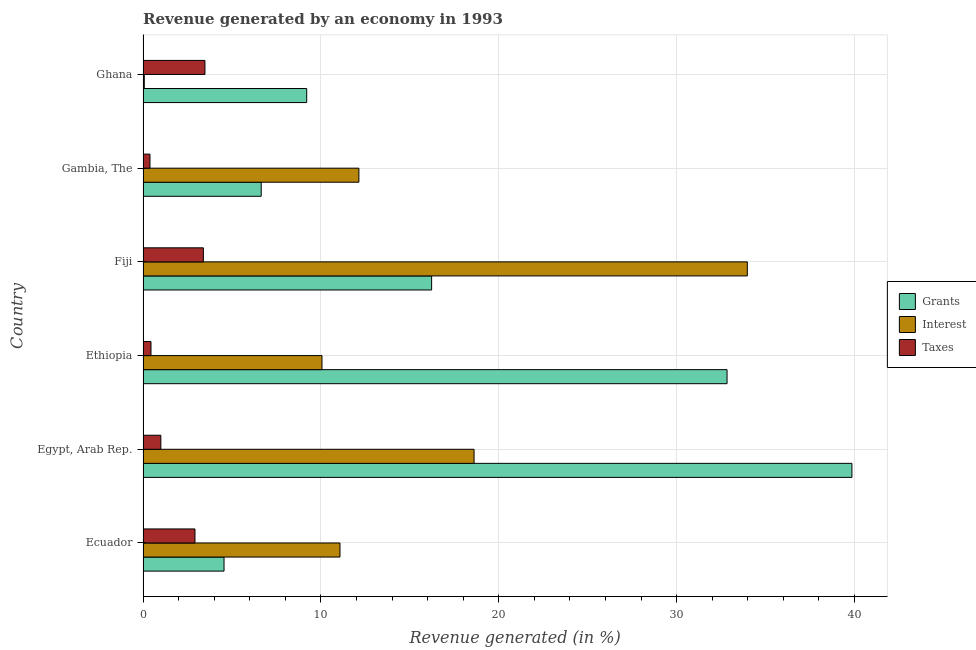How many different coloured bars are there?
Your response must be concise. 3. How many groups of bars are there?
Provide a succinct answer. 6. Are the number of bars per tick equal to the number of legend labels?
Give a very brief answer. Yes. How many bars are there on the 6th tick from the bottom?
Offer a very short reply. 3. What is the label of the 5th group of bars from the top?
Your answer should be very brief. Egypt, Arab Rep. What is the percentage of revenue generated by interest in Fiji?
Provide a succinct answer. 33.97. Across all countries, what is the maximum percentage of revenue generated by interest?
Make the answer very short. 33.97. Across all countries, what is the minimum percentage of revenue generated by taxes?
Your answer should be compact. 0.39. In which country was the percentage of revenue generated by interest maximum?
Keep it short and to the point. Fiji. In which country was the percentage of revenue generated by interest minimum?
Make the answer very short. Ghana. What is the total percentage of revenue generated by interest in the graph?
Your answer should be very brief. 85.92. What is the difference between the percentage of revenue generated by grants in Ethiopia and that in Gambia, The?
Ensure brevity in your answer.  26.19. What is the difference between the percentage of revenue generated by taxes in Ecuador and the percentage of revenue generated by grants in Ethiopia?
Offer a very short reply. -29.92. What is the average percentage of revenue generated by interest per country?
Offer a terse response. 14.32. What is the difference between the percentage of revenue generated by taxes and percentage of revenue generated by interest in Ethiopia?
Make the answer very short. -9.61. What is the ratio of the percentage of revenue generated by grants in Ethiopia to that in Fiji?
Provide a succinct answer. 2.02. Is the percentage of revenue generated by taxes in Egypt, Arab Rep. less than that in Gambia, The?
Your answer should be compact. No. Is the difference between the percentage of revenue generated by taxes in Ecuador and Egypt, Arab Rep. greater than the difference between the percentage of revenue generated by grants in Ecuador and Egypt, Arab Rep.?
Provide a succinct answer. Yes. What is the difference between the highest and the second highest percentage of revenue generated by grants?
Offer a terse response. 7.02. What is the difference between the highest and the lowest percentage of revenue generated by taxes?
Offer a terse response. 3.09. Is the sum of the percentage of revenue generated by taxes in Ecuador and Fiji greater than the maximum percentage of revenue generated by interest across all countries?
Make the answer very short. No. What does the 2nd bar from the top in Ethiopia represents?
Your answer should be compact. Interest. What does the 3rd bar from the bottom in Gambia, The represents?
Keep it short and to the point. Taxes. Is it the case that in every country, the sum of the percentage of revenue generated by grants and percentage of revenue generated by interest is greater than the percentage of revenue generated by taxes?
Your answer should be compact. Yes. Are all the bars in the graph horizontal?
Your answer should be very brief. Yes. How many countries are there in the graph?
Offer a terse response. 6. What is the difference between two consecutive major ticks on the X-axis?
Your response must be concise. 10. Are the values on the major ticks of X-axis written in scientific E-notation?
Ensure brevity in your answer.  No. Does the graph contain any zero values?
Give a very brief answer. No. Where does the legend appear in the graph?
Your response must be concise. Center right. How are the legend labels stacked?
Give a very brief answer. Vertical. What is the title of the graph?
Give a very brief answer. Revenue generated by an economy in 1993. Does "Methane" appear as one of the legend labels in the graph?
Provide a succinct answer. No. What is the label or title of the X-axis?
Offer a very short reply. Revenue generated (in %). What is the Revenue generated (in %) of Grants in Ecuador?
Make the answer very short. 4.55. What is the Revenue generated (in %) of Interest in Ecuador?
Provide a short and direct response. 11.07. What is the Revenue generated (in %) in Taxes in Ecuador?
Ensure brevity in your answer.  2.92. What is the Revenue generated (in %) of Grants in Egypt, Arab Rep.?
Keep it short and to the point. 39.86. What is the Revenue generated (in %) in Interest in Egypt, Arab Rep.?
Your response must be concise. 18.61. What is the Revenue generated (in %) in Taxes in Egypt, Arab Rep.?
Offer a very short reply. 1. What is the Revenue generated (in %) of Grants in Ethiopia?
Provide a succinct answer. 32.83. What is the Revenue generated (in %) in Interest in Ethiopia?
Offer a terse response. 10.06. What is the Revenue generated (in %) of Taxes in Ethiopia?
Offer a terse response. 0.45. What is the Revenue generated (in %) in Grants in Fiji?
Your answer should be compact. 16.22. What is the Revenue generated (in %) of Interest in Fiji?
Provide a short and direct response. 33.97. What is the Revenue generated (in %) in Taxes in Fiji?
Ensure brevity in your answer.  3.39. What is the Revenue generated (in %) of Grants in Gambia, The?
Keep it short and to the point. 6.64. What is the Revenue generated (in %) in Interest in Gambia, The?
Give a very brief answer. 12.13. What is the Revenue generated (in %) in Taxes in Gambia, The?
Offer a very short reply. 0.39. What is the Revenue generated (in %) of Grants in Ghana?
Provide a short and direct response. 9.2. What is the Revenue generated (in %) of Interest in Ghana?
Provide a succinct answer. 0.07. What is the Revenue generated (in %) of Taxes in Ghana?
Provide a succinct answer. 3.48. Across all countries, what is the maximum Revenue generated (in %) in Grants?
Your answer should be very brief. 39.86. Across all countries, what is the maximum Revenue generated (in %) of Interest?
Provide a short and direct response. 33.97. Across all countries, what is the maximum Revenue generated (in %) of Taxes?
Offer a very short reply. 3.48. Across all countries, what is the minimum Revenue generated (in %) in Grants?
Make the answer very short. 4.55. Across all countries, what is the minimum Revenue generated (in %) in Interest?
Give a very brief answer. 0.07. Across all countries, what is the minimum Revenue generated (in %) of Taxes?
Ensure brevity in your answer.  0.39. What is the total Revenue generated (in %) of Grants in the graph?
Provide a short and direct response. 109.31. What is the total Revenue generated (in %) in Interest in the graph?
Keep it short and to the point. 85.92. What is the total Revenue generated (in %) of Taxes in the graph?
Give a very brief answer. 11.62. What is the difference between the Revenue generated (in %) of Grants in Ecuador and that in Egypt, Arab Rep.?
Make the answer very short. -35.3. What is the difference between the Revenue generated (in %) of Interest in Ecuador and that in Egypt, Arab Rep.?
Your answer should be very brief. -7.54. What is the difference between the Revenue generated (in %) of Taxes in Ecuador and that in Egypt, Arab Rep.?
Your answer should be very brief. 1.92. What is the difference between the Revenue generated (in %) in Grants in Ecuador and that in Ethiopia?
Provide a succinct answer. -28.28. What is the difference between the Revenue generated (in %) of Interest in Ecuador and that in Ethiopia?
Your response must be concise. 1.01. What is the difference between the Revenue generated (in %) in Taxes in Ecuador and that in Ethiopia?
Keep it short and to the point. 2.47. What is the difference between the Revenue generated (in %) of Grants in Ecuador and that in Fiji?
Offer a very short reply. -11.67. What is the difference between the Revenue generated (in %) of Interest in Ecuador and that in Fiji?
Your answer should be compact. -22.9. What is the difference between the Revenue generated (in %) of Taxes in Ecuador and that in Fiji?
Your answer should be very brief. -0.47. What is the difference between the Revenue generated (in %) of Grants in Ecuador and that in Gambia, The?
Offer a terse response. -2.09. What is the difference between the Revenue generated (in %) of Interest in Ecuador and that in Gambia, The?
Offer a terse response. -1.06. What is the difference between the Revenue generated (in %) in Taxes in Ecuador and that in Gambia, The?
Give a very brief answer. 2.53. What is the difference between the Revenue generated (in %) of Grants in Ecuador and that in Ghana?
Provide a succinct answer. -4.65. What is the difference between the Revenue generated (in %) of Interest in Ecuador and that in Ghana?
Your answer should be compact. 11. What is the difference between the Revenue generated (in %) in Taxes in Ecuador and that in Ghana?
Provide a succinct answer. -0.56. What is the difference between the Revenue generated (in %) of Grants in Egypt, Arab Rep. and that in Ethiopia?
Offer a terse response. 7.02. What is the difference between the Revenue generated (in %) in Interest in Egypt, Arab Rep. and that in Ethiopia?
Keep it short and to the point. 8.55. What is the difference between the Revenue generated (in %) in Taxes in Egypt, Arab Rep. and that in Ethiopia?
Give a very brief answer. 0.55. What is the difference between the Revenue generated (in %) of Grants in Egypt, Arab Rep. and that in Fiji?
Make the answer very short. 23.63. What is the difference between the Revenue generated (in %) of Interest in Egypt, Arab Rep. and that in Fiji?
Provide a succinct answer. -15.36. What is the difference between the Revenue generated (in %) of Taxes in Egypt, Arab Rep. and that in Fiji?
Give a very brief answer. -2.39. What is the difference between the Revenue generated (in %) of Grants in Egypt, Arab Rep. and that in Gambia, The?
Your response must be concise. 33.21. What is the difference between the Revenue generated (in %) of Interest in Egypt, Arab Rep. and that in Gambia, The?
Your response must be concise. 6.48. What is the difference between the Revenue generated (in %) of Taxes in Egypt, Arab Rep. and that in Gambia, The?
Ensure brevity in your answer.  0.61. What is the difference between the Revenue generated (in %) of Grants in Egypt, Arab Rep. and that in Ghana?
Your answer should be compact. 30.66. What is the difference between the Revenue generated (in %) in Interest in Egypt, Arab Rep. and that in Ghana?
Offer a very short reply. 18.54. What is the difference between the Revenue generated (in %) of Taxes in Egypt, Arab Rep. and that in Ghana?
Provide a short and direct response. -2.48. What is the difference between the Revenue generated (in %) of Grants in Ethiopia and that in Fiji?
Your answer should be very brief. 16.61. What is the difference between the Revenue generated (in %) of Interest in Ethiopia and that in Fiji?
Your answer should be very brief. -23.91. What is the difference between the Revenue generated (in %) in Taxes in Ethiopia and that in Fiji?
Keep it short and to the point. -2.95. What is the difference between the Revenue generated (in %) in Grants in Ethiopia and that in Gambia, The?
Offer a very short reply. 26.19. What is the difference between the Revenue generated (in %) of Interest in Ethiopia and that in Gambia, The?
Provide a succinct answer. -2.08. What is the difference between the Revenue generated (in %) of Taxes in Ethiopia and that in Gambia, The?
Ensure brevity in your answer.  0.06. What is the difference between the Revenue generated (in %) in Grants in Ethiopia and that in Ghana?
Your response must be concise. 23.63. What is the difference between the Revenue generated (in %) in Interest in Ethiopia and that in Ghana?
Keep it short and to the point. 9.99. What is the difference between the Revenue generated (in %) in Taxes in Ethiopia and that in Ghana?
Offer a very short reply. -3.03. What is the difference between the Revenue generated (in %) of Grants in Fiji and that in Gambia, The?
Ensure brevity in your answer.  9.58. What is the difference between the Revenue generated (in %) of Interest in Fiji and that in Gambia, The?
Provide a succinct answer. 21.84. What is the difference between the Revenue generated (in %) of Taxes in Fiji and that in Gambia, The?
Provide a succinct answer. 3. What is the difference between the Revenue generated (in %) of Grants in Fiji and that in Ghana?
Your answer should be very brief. 7.02. What is the difference between the Revenue generated (in %) in Interest in Fiji and that in Ghana?
Give a very brief answer. 33.91. What is the difference between the Revenue generated (in %) in Taxes in Fiji and that in Ghana?
Give a very brief answer. -0.09. What is the difference between the Revenue generated (in %) of Grants in Gambia, The and that in Ghana?
Ensure brevity in your answer.  -2.56. What is the difference between the Revenue generated (in %) in Interest in Gambia, The and that in Ghana?
Make the answer very short. 12.07. What is the difference between the Revenue generated (in %) of Taxes in Gambia, The and that in Ghana?
Offer a very short reply. -3.09. What is the difference between the Revenue generated (in %) in Grants in Ecuador and the Revenue generated (in %) in Interest in Egypt, Arab Rep.?
Offer a very short reply. -14.06. What is the difference between the Revenue generated (in %) of Grants in Ecuador and the Revenue generated (in %) of Taxes in Egypt, Arab Rep.?
Your answer should be very brief. 3.55. What is the difference between the Revenue generated (in %) in Interest in Ecuador and the Revenue generated (in %) in Taxes in Egypt, Arab Rep.?
Your answer should be very brief. 10.07. What is the difference between the Revenue generated (in %) of Grants in Ecuador and the Revenue generated (in %) of Interest in Ethiopia?
Provide a short and direct response. -5.51. What is the difference between the Revenue generated (in %) of Grants in Ecuador and the Revenue generated (in %) of Taxes in Ethiopia?
Provide a short and direct response. 4.11. What is the difference between the Revenue generated (in %) in Interest in Ecuador and the Revenue generated (in %) in Taxes in Ethiopia?
Provide a succinct answer. 10.63. What is the difference between the Revenue generated (in %) of Grants in Ecuador and the Revenue generated (in %) of Interest in Fiji?
Provide a short and direct response. -29.42. What is the difference between the Revenue generated (in %) in Grants in Ecuador and the Revenue generated (in %) in Taxes in Fiji?
Provide a succinct answer. 1.16. What is the difference between the Revenue generated (in %) of Interest in Ecuador and the Revenue generated (in %) of Taxes in Fiji?
Provide a short and direct response. 7.68. What is the difference between the Revenue generated (in %) in Grants in Ecuador and the Revenue generated (in %) in Interest in Gambia, The?
Your answer should be very brief. -7.58. What is the difference between the Revenue generated (in %) of Grants in Ecuador and the Revenue generated (in %) of Taxes in Gambia, The?
Keep it short and to the point. 4.16. What is the difference between the Revenue generated (in %) in Interest in Ecuador and the Revenue generated (in %) in Taxes in Gambia, The?
Offer a very short reply. 10.68. What is the difference between the Revenue generated (in %) of Grants in Ecuador and the Revenue generated (in %) of Interest in Ghana?
Make the answer very short. 4.48. What is the difference between the Revenue generated (in %) in Grants in Ecuador and the Revenue generated (in %) in Taxes in Ghana?
Provide a short and direct response. 1.07. What is the difference between the Revenue generated (in %) in Interest in Ecuador and the Revenue generated (in %) in Taxes in Ghana?
Offer a terse response. 7.59. What is the difference between the Revenue generated (in %) in Grants in Egypt, Arab Rep. and the Revenue generated (in %) in Interest in Ethiopia?
Provide a short and direct response. 29.8. What is the difference between the Revenue generated (in %) of Grants in Egypt, Arab Rep. and the Revenue generated (in %) of Taxes in Ethiopia?
Make the answer very short. 39.41. What is the difference between the Revenue generated (in %) in Interest in Egypt, Arab Rep. and the Revenue generated (in %) in Taxes in Ethiopia?
Provide a succinct answer. 18.16. What is the difference between the Revenue generated (in %) of Grants in Egypt, Arab Rep. and the Revenue generated (in %) of Interest in Fiji?
Provide a short and direct response. 5.88. What is the difference between the Revenue generated (in %) in Grants in Egypt, Arab Rep. and the Revenue generated (in %) in Taxes in Fiji?
Your response must be concise. 36.46. What is the difference between the Revenue generated (in %) of Interest in Egypt, Arab Rep. and the Revenue generated (in %) of Taxes in Fiji?
Provide a succinct answer. 15.22. What is the difference between the Revenue generated (in %) of Grants in Egypt, Arab Rep. and the Revenue generated (in %) of Interest in Gambia, The?
Your answer should be very brief. 27.72. What is the difference between the Revenue generated (in %) in Grants in Egypt, Arab Rep. and the Revenue generated (in %) in Taxes in Gambia, The?
Your response must be concise. 39.47. What is the difference between the Revenue generated (in %) in Interest in Egypt, Arab Rep. and the Revenue generated (in %) in Taxes in Gambia, The?
Your answer should be compact. 18.22. What is the difference between the Revenue generated (in %) of Grants in Egypt, Arab Rep. and the Revenue generated (in %) of Interest in Ghana?
Offer a terse response. 39.79. What is the difference between the Revenue generated (in %) of Grants in Egypt, Arab Rep. and the Revenue generated (in %) of Taxes in Ghana?
Give a very brief answer. 36.38. What is the difference between the Revenue generated (in %) of Interest in Egypt, Arab Rep. and the Revenue generated (in %) of Taxes in Ghana?
Provide a succinct answer. 15.13. What is the difference between the Revenue generated (in %) of Grants in Ethiopia and the Revenue generated (in %) of Interest in Fiji?
Provide a succinct answer. -1.14. What is the difference between the Revenue generated (in %) in Grants in Ethiopia and the Revenue generated (in %) in Taxes in Fiji?
Make the answer very short. 29.44. What is the difference between the Revenue generated (in %) in Interest in Ethiopia and the Revenue generated (in %) in Taxes in Fiji?
Give a very brief answer. 6.67. What is the difference between the Revenue generated (in %) in Grants in Ethiopia and the Revenue generated (in %) in Interest in Gambia, The?
Your response must be concise. 20.7. What is the difference between the Revenue generated (in %) of Grants in Ethiopia and the Revenue generated (in %) of Taxes in Gambia, The?
Your answer should be very brief. 32.45. What is the difference between the Revenue generated (in %) of Interest in Ethiopia and the Revenue generated (in %) of Taxes in Gambia, The?
Make the answer very short. 9.67. What is the difference between the Revenue generated (in %) of Grants in Ethiopia and the Revenue generated (in %) of Interest in Ghana?
Give a very brief answer. 32.77. What is the difference between the Revenue generated (in %) in Grants in Ethiopia and the Revenue generated (in %) in Taxes in Ghana?
Keep it short and to the point. 29.36. What is the difference between the Revenue generated (in %) in Interest in Ethiopia and the Revenue generated (in %) in Taxes in Ghana?
Your answer should be compact. 6.58. What is the difference between the Revenue generated (in %) in Grants in Fiji and the Revenue generated (in %) in Interest in Gambia, The?
Your answer should be very brief. 4.09. What is the difference between the Revenue generated (in %) in Grants in Fiji and the Revenue generated (in %) in Taxes in Gambia, The?
Make the answer very short. 15.84. What is the difference between the Revenue generated (in %) in Interest in Fiji and the Revenue generated (in %) in Taxes in Gambia, The?
Ensure brevity in your answer.  33.59. What is the difference between the Revenue generated (in %) in Grants in Fiji and the Revenue generated (in %) in Interest in Ghana?
Provide a succinct answer. 16.16. What is the difference between the Revenue generated (in %) in Grants in Fiji and the Revenue generated (in %) in Taxes in Ghana?
Your response must be concise. 12.75. What is the difference between the Revenue generated (in %) of Interest in Fiji and the Revenue generated (in %) of Taxes in Ghana?
Provide a succinct answer. 30.49. What is the difference between the Revenue generated (in %) of Grants in Gambia, The and the Revenue generated (in %) of Interest in Ghana?
Keep it short and to the point. 6.58. What is the difference between the Revenue generated (in %) of Grants in Gambia, The and the Revenue generated (in %) of Taxes in Ghana?
Your response must be concise. 3.16. What is the difference between the Revenue generated (in %) in Interest in Gambia, The and the Revenue generated (in %) in Taxes in Ghana?
Your answer should be compact. 8.66. What is the average Revenue generated (in %) of Grants per country?
Provide a succinct answer. 18.22. What is the average Revenue generated (in %) of Interest per country?
Provide a succinct answer. 14.32. What is the average Revenue generated (in %) in Taxes per country?
Provide a succinct answer. 1.94. What is the difference between the Revenue generated (in %) in Grants and Revenue generated (in %) in Interest in Ecuador?
Keep it short and to the point. -6.52. What is the difference between the Revenue generated (in %) in Grants and Revenue generated (in %) in Taxes in Ecuador?
Your response must be concise. 1.63. What is the difference between the Revenue generated (in %) in Interest and Revenue generated (in %) in Taxes in Ecuador?
Offer a very short reply. 8.15. What is the difference between the Revenue generated (in %) in Grants and Revenue generated (in %) in Interest in Egypt, Arab Rep.?
Offer a very short reply. 21.25. What is the difference between the Revenue generated (in %) in Grants and Revenue generated (in %) in Taxes in Egypt, Arab Rep.?
Make the answer very short. 38.86. What is the difference between the Revenue generated (in %) of Interest and Revenue generated (in %) of Taxes in Egypt, Arab Rep.?
Give a very brief answer. 17.61. What is the difference between the Revenue generated (in %) of Grants and Revenue generated (in %) of Interest in Ethiopia?
Give a very brief answer. 22.78. What is the difference between the Revenue generated (in %) of Grants and Revenue generated (in %) of Taxes in Ethiopia?
Provide a short and direct response. 32.39. What is the difference between the Revenue generated (in %) in Interest and Revenue generated (in %) in Taxes in Ethiopia?
Offer a very short reply. 9.61. What is the difference between the Revenue generated (in %) in Grants and Revenue generated (in %) in Interest in Fiji?
Offer a terse response. -17.75. What is the difference between the Revenue generated (in %) in Grants and Revenue generated (in %) in Taxes in Fiji?
Keep it short and to the point. 12.83. What is the difference between the Revenue generated (in %) of Interest and Revenue generated (in %) of Taxes in Fiji?
Offer a terse response. 30.58. What is the difference between the Revenue generated (in %) in Grants and Revenue generated (in %) in Interest in Gambia, The?
Your answer should be very brief. -5.49. What is the difference between the Revenue generated (in %) of Grants and Revenue generated (in %) of Taxes in Gambia, The?
Provide a succinct answer. 6.26. What is the difference between the Revenue generated (in %) of Interest and Revenue generated (in %) of Taxes in Gambia, The?
Your answer should be compact. 11.75. What is the difference between the Revenue generated (in %) in Grants and Revenue generated (in %) in Interest in Ghana?
Ensure brevity in your answer.  9.13. What is the difference between the Revenue generated (in %) of Grants and Revenue generated (in %) of Taxes in Ghana?
Provide a succinct answer. 5.72. What is the difference between the Revenue generated (in %) in Interest and Revenue generated (in %) in Taxes in Ghana?
Your answer should be compact. -3.41. What is the ratio of the Revenue generated (in %) in Grants in Ecuador to that in Egypt, Arab Rep.?
Provide a short and direct response. 0.11. What is the ratio of the Revenue generated (in %) of Interest in Ecuador to that in Egypt, Arab Rep.?
Provide a succinct answer. 0.59. What is the ratio of the Revenue generated (in %) of Taxes in Ecuador to that in Egypt, Arab Rep.?
Provide a short and direct response. 2.92. What is the ratio of the Revenue generated (in %) in Grants in Ecuador to that in Ethiopia?
Provide a short and direct response. 0.14. What is the ratio of the Revenue generated (in %) in Interest in Ecuador to that in Ethiopia?
Give a very brief answer. 1.1. What is the ratio of the Revenue generated (in %) of Taxes in Ecuador to that in Ethiopia?
Your answer should be very brief. 6.55. What is the ratio of the Revenue generated (in %) of Grants in Ecuador to that in Fiji?
Provide a succinct answer. 0.28. What is the ratio of the Revenue generated (in %) in Interest in Ecuador to that in Fiji?
Your response must be concise. 0.33. What is the ratio of the Revenue generated (in %) in Taxes in Ecuador to that in Fiji?
Offer a very short reply. 0.86. What is the ratio of the Revenue generated (in %) of Grants in Ecuador to that in Gambia, The?
Provide a short and direct response. 0.69. What is the ratio of the Revenue generated (in %) in Interest in Ecuador to that in Gambia, The?
Your answer should be very brief. 0.91. What is the ratio of the Revenue generated (in %) of Taxes in Ecuador to that in Gambia, The?
Keep it short and to the point. 7.52. What is the ratio of the Revenue generated (in %) in Grants in Ecuador to that in Ghana?
Ensure brevity in your answer.  0.49. What is the ratio of the Revenue generated (in %) in Interest in Ecuador to that in Ghana?
Your answer should be compact. 161.86. What is the ratio of the Revenue generated (in %) of Taxes in Ecuador to that in Ghana?
Give a very brief answer. 0.84. What is the ratio of the Revenue generated (in %) in Grants in Egypt, Arab Rep. to that in Ethiopia?
Your response must be concise. 1.21. What is the ratio of the Revenue generated (in %) of Interest in Egypt, Arab Rep. to that in Ethiopia?
Provide a short and direct response. 1.85. What is the ratio of the Revenue generated (in %) in Taxes in Egypt, Arab Rep. to that in Ethiopia?
Keep it short and to the point. 2.24. What is the ratio of the Revenue generated (in %) of Grants in Egypt, Arab Rep. to that in Fiji?
Provide a succinct answer. 2.46. What is the ratio of the Revenue generated (in %) in Interest in Egypt, Arab Rep. to that in Fiji?
Keep it short and to the point. 0.55. What is the ratio of the Revenue generated (in %) in Taxes in Egypt, Arab Rep. to that in Fiji?
Offer a very short reply. 0.29. What is the ratio of the Revenue generated (in %) of Grants in Egypt, Arab Rep. to that in Gambia, The?
Give a very brief answer. 6. What is the ratio of the Revenue generated (in %) in Interest in Egypt, Arab Rep. to that in Gambia, The?
Your answer should be compact. 1.53. What is the ratio of the Revenue generated (in %) of Taxes in Egypt, Arab Rep. to that in Gambia, The?
Your response must be concise. 2.57. What is the ratio of the Revenue generated (in %) of Grants in Egypt, Arab Rep. to that in Ghana?
Your answer should be compact. 4.33. What is the ratio of the Revenue generated (in %) of Interest in Egypt, Arab Rep. to that in Ghana?
Your answer should be compact. 272.08. What is the ratio of the Revenue generated (in %) of Taxes in Egypt, Arab Rep. to that in Ghana?
Offer a very short reply. 0.29. What is the ratio of the Revenue generated (in %) in Grants in Ethiopia to that in Fiji?
Provide a short and direct response. 2.02. What is the ratio of the Revenue generated (in %) in Interest in Ethiopia to that in Fiji?
Keep it short and to the point. 0.3. What is the ratio of the Revenue generated (in %) of Taxes in Ethiopia to that in Fiji?
Offer a terse response. 0.13. What is the ratio of the Revenue generated (in %) of Grants in Ethiopia to that in Gambia, The?
Your answer should be compact. 4.94. What is the ratio of the Revenue generated (in %) in Interest in Ethiopia to that in Gambia, The?
Provide a short and direct response. 0.83. What is the ratio of the Revenue generated (in %) of Taxes in Ethiopia to that in Gambia, The?
Keep it short and to the point. 1.15. What is the ratio of the Revenue generated (in %) of Grants in Ethiopia to that in Ghana?
Your answer should be very brief. 3.57. What is the ratio of the Revenue generated (in %) in Interest in Ethiopia to that in Ghana?
Your answer should be compact. 147.07. What is the ratio of the Revenue generated (in %) in Taxes in Ethiopia to that in Ghana?
Keep it short and to the point. 0.13. What is the ratio of the Revenue generated (in %) of Grants in Fiji to that in Gambia, The?
Your answer should be compact. 2.44. What is the ratio of the Revenue generated (in %) in Interest in Fiji to that in Gambia, The?
Provide a succinct answer. 2.8. What is the ratio of the Revenue generated (in %) in Taxes in Fiji to that in Gambia, The?
Your answer should be compact. 8.74. What is the ratio of the Revenue generated (in %) in Grants in Fiji to that in Ghana?
Keep it short and to the point. 1.76. What is the ratio of the Revenue generated (in %) in Interest in Fiji to that in Ghana?
Your answer should be very brief. 496.7. What is the ratio of the Revenue generated (in %) of Taxes in Fiji to that in Ghana?
Offer a terse response. 0.97. What is the ratio of the Revenue generated (in %) in Grants in Gambia, The to that in Ghana?
Provide a short and direct response. 0.72. What is the ratio of the Revenue generated (in %) in Interest in Gambia, The to that in Ghana?
Your response must be concise. 177.41. What is the ratio of the Revenue generated (in %) of Taxes in Gambia, The to that in Ghana?
Offer a very short reply. 0.11. What is the difference between the highest and the second highest Revenue generated (in %) in Grants?
Offer a very short reply. 7.02. What is the difference between the highest and the second highest Revenue generated (in %) of Interest?
Offer a terse response. 15.36. What is the difference between the highest and the second highest Revenue generated (in %) in Taxes?
Your answer should be very brief. 0.09. What is the difference between the highest and the lowest Revenue generated (in %) of Grants?
Your response must be concise. 35.3. What is the difference between the highest and the lowest Revenue generated (in %) of Interest?
Your response must be concise. 33.91. What is the difference between the highest and the lowest Revenue generated (in %) of Taxes?
Ensure brevity in your answer.  3.09. 